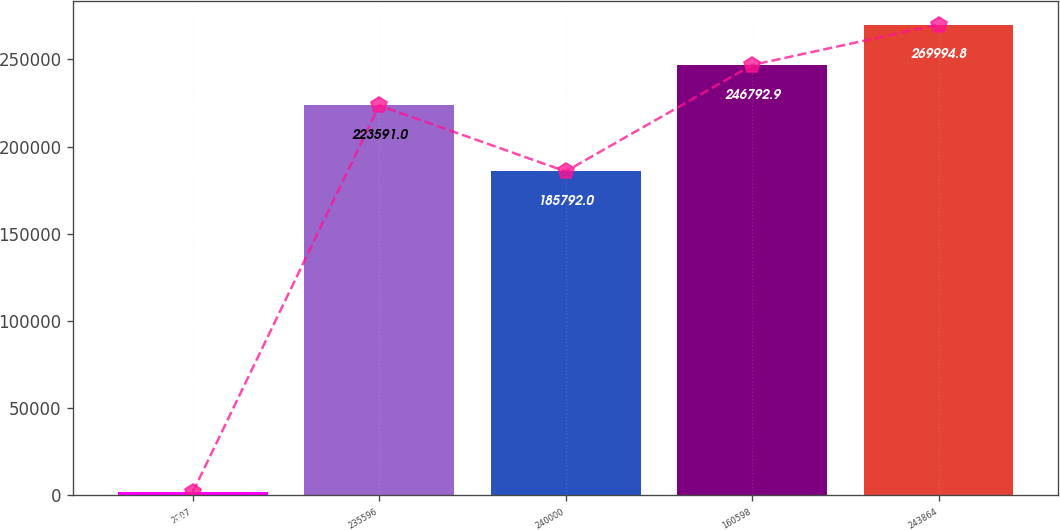Convert chart to OTSL. <chart><loc_0><loc_0><loc_500><loc_500><bar_chart><fcel>2007<fcel>235596<fcel>240000<fcel>160598<fcel>243864<nl><fcel>2005<fcel>223591<fcel>185792<fcel>246793<fcel>269995<nl></chart> 